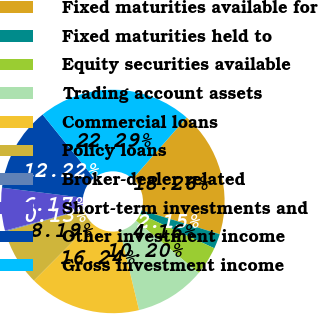<chart> <loc_0><loc_0><loc_500><loc_500><pie_chart><fcel>Fixed maturities available for<fcel>Fixed maturities held to<fcel>Equity securities available<fcel>Trading account assets<fcel>Commercial loans<fcel>Policy loans<fcel>Broker-dealer related<fcel>Short-term investments and<fcel>Other investment income<fcel>Gross investment income<nl><fcel>18.26%<fcel>2.15%<fcel>4.16%<fcel>10.2%<fcel>16.24%<fcel>8.19%<fcel>0.13%<fcel>6.17%<fcel>12.22%<fcel>22.29%<nl></chart> 